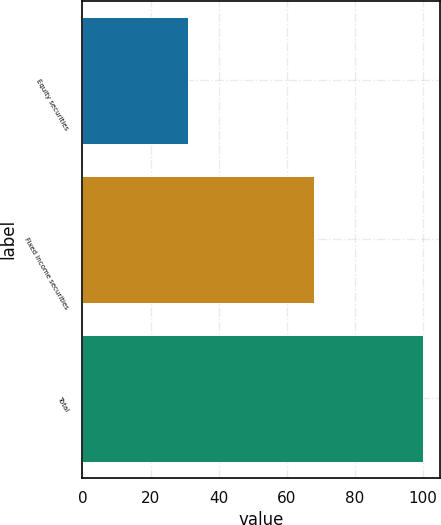Convert chart to OTSL. <chart><loc_0><loc_0><loc_500><loc_500><bar_chart><fcel>Equity securities<fcel>Fixed income securities<fcel>Total<nl><fcel>31<fcel>68<fcel>100<nl></chart> 